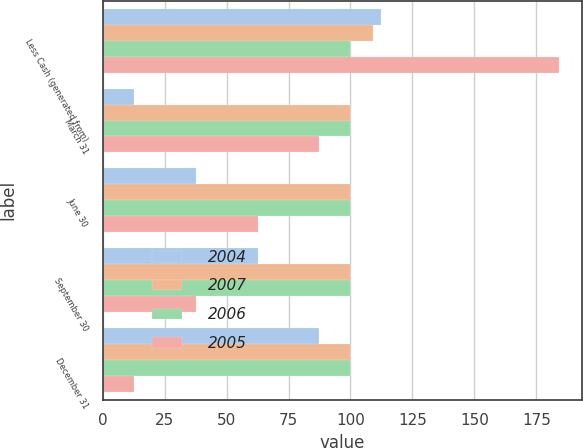Convert chart to OTSL. <chart><loc_0><loc_0><loc_500><loc_500><stacked_bar_chart><ecel><fcel>Less Cash (generated from)<fcel>March 31<fcel>June 30<fcel>September 30<fcel>December 31<nl><fcel>2004<fcel>112.5<fcel>12.5<fcel>37.5<fcel>62.5<fcel>87.5<nl><fcel>2007<fcel>109<fcel>100<fcel>100<fcel>100<fcel>100<nl><fcel>2006<fcel>100<fcel>100<fcel>100<fcel>100<fcel>100<nl><fcel>2005<fcel>184.3<fcel>87.5<fcel>62.5<fcel>37.5<fcel>12.5<nl></chart> 